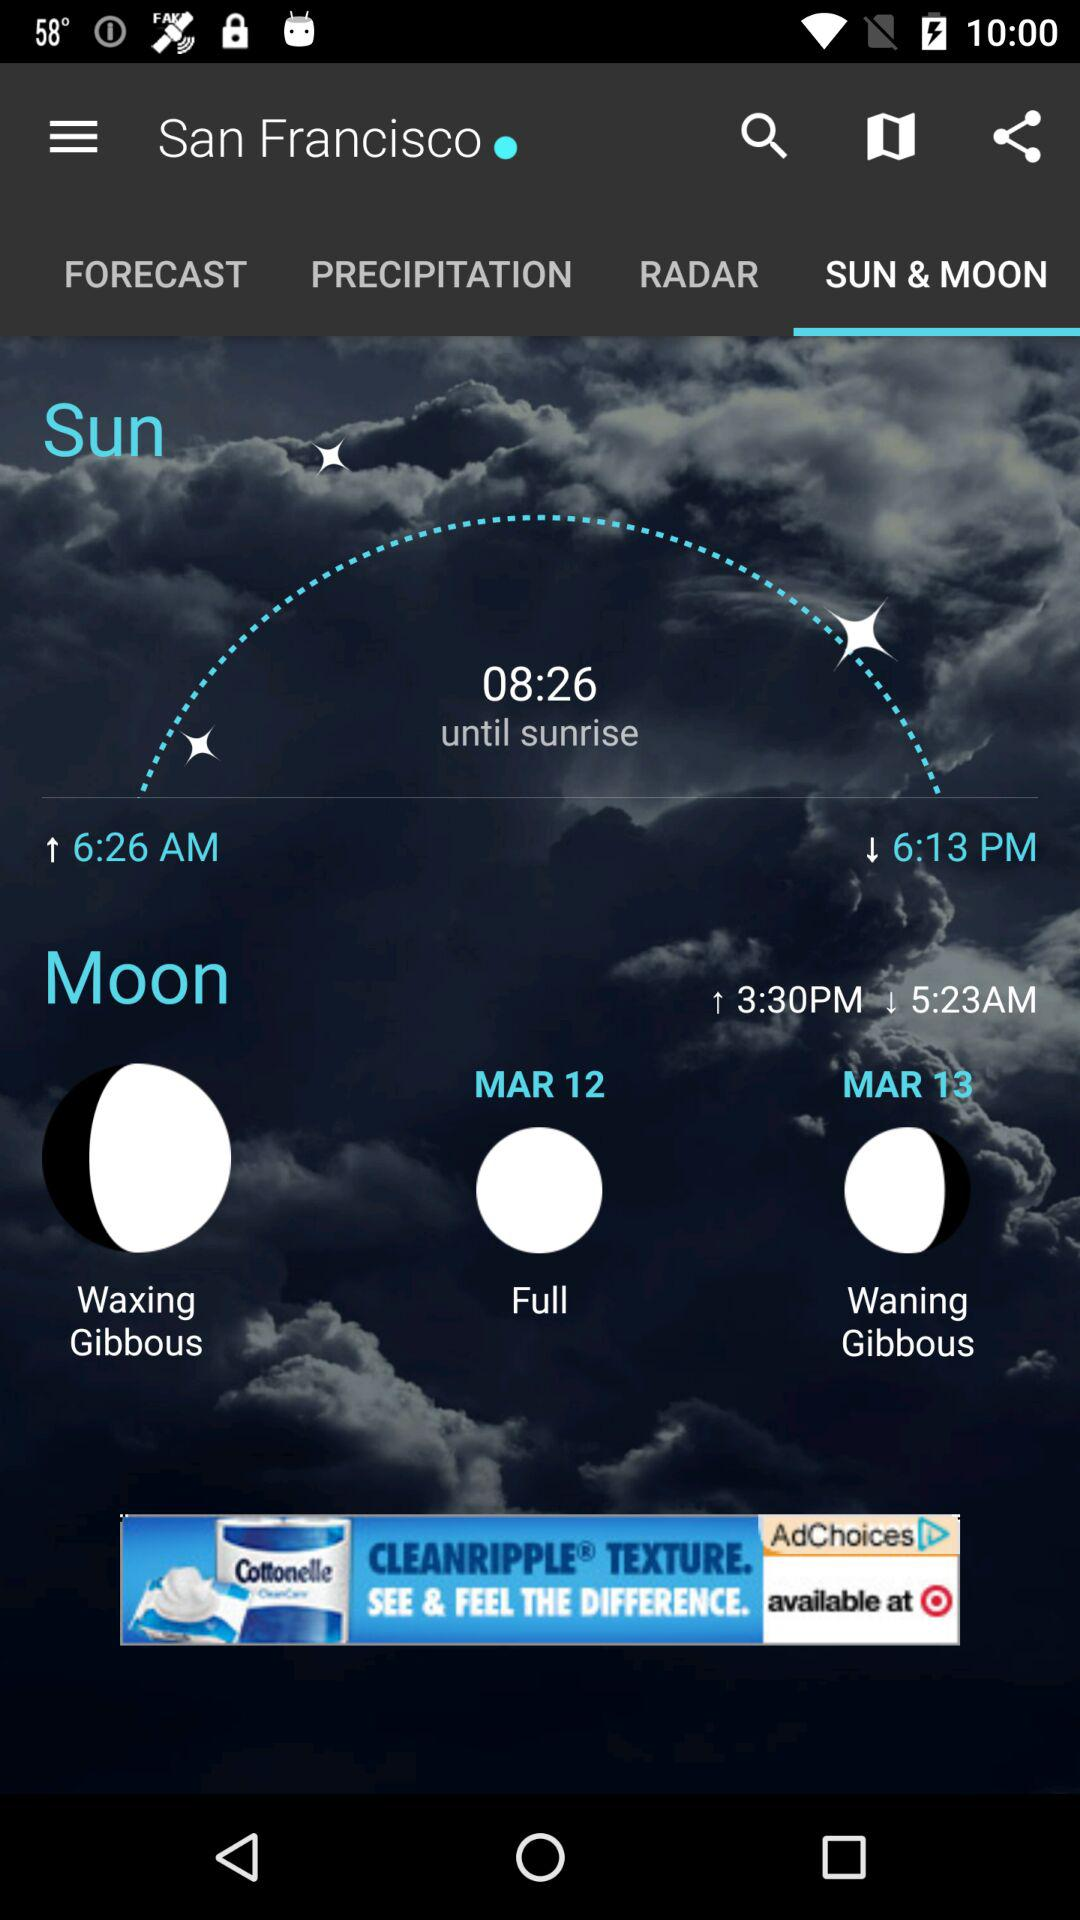How much time is left until sunrise? The left time is 8 hours 26 minutes. 